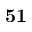<formula> <loc_0><loc_0><loc_500><loc_500>5 1</formula> 